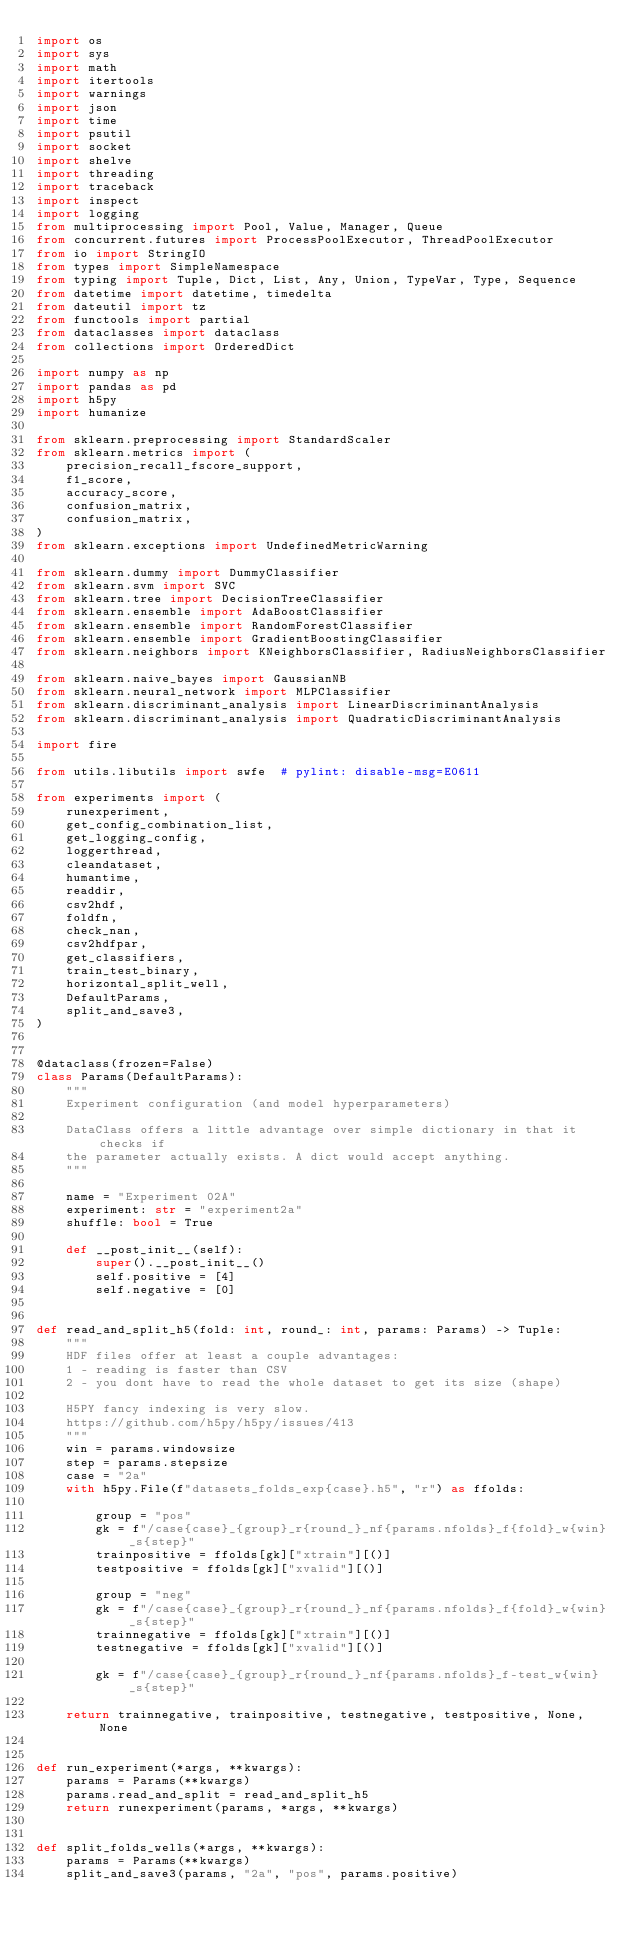Convert code to text. <code><loc_0><loc_0><loc_500><loc_500><_Python_>import os
import sys
import math
import itertools
import warnings
import json
import time
import psutil
import socket
import shelve
import threading
import traceback
import inspect
import logging
from multiprocessing import Pool, Value, Manager, Queue
from concurrent.futures import ProcessPoolExecutor, ThreadPoolExecutor
from io import StringIO
from types import SimpleNamespace
from typing import Tuple, Dict, List, Any, Union, TypeVar, Type, Sequence
from datetime import datetime, timedelta
from dateutil import tz
from functools import partial
from dataclasses import dataclass
from collections import OrderedDict

import numpy as np
import pandas as pd
import h5py
import humanize

from sklearn.preprocessing import StandardScaler
from sklearn.metrics import (
    precision_recall_fscore_support,
    f1_score,
    accuracy_score,
    confusion_matrix,
    confusion_matrix,
)
from sklearn.exceptions import UndefinedMetricWarning

from sklearn.dummy import DummyClassifier
from sklearn.svm import SVC
from sklearn.tree import DecisionTreeClassifier
from sklearn.ensemble import AdaBoostClassifier
from sklearn.ensemble import RandomForestClassifier
from sklearn.ensemble import GradientBoostingClassifier
from sklearn.neighbors import KNeighborsClassifier, RadiusNeighborsClassifier

from sklearn.naive_bayes import GaussianNB
from sklearn.neural_network import MLPClassifier
from sklearn.discriminant_analysis import LinearDiscriminantAnalysis
from sklearn.discriminant_analysis import QuadraticDiscriminantAnalysis

import fire

from utils.libutils import swfe  # pylint: disable-msg=E0611

from experiments import (
    runexperiment,
    get_config_combination_list,
    get_logging_config,
    loggerthread,
    cleandataset,
    humantime,
    readdir,
    csv2hdf,
    foldfn,
    check_nan,
    csv2hdfpar,
    get_classifiers,
    train_test_binary,
    horizontal_split_well,
    DefaultParams,
    split_and_save3,
)


@dataclass(frozen=False)
class Params(DefaultParams):
    """
    Experiment configuration (and model hyperparameters)

    DataClass offers a little advantage over simple dictionary in that it checks if
    the parameter actually exists. A dict would accept anything.
    """

    name = "Experiment 02A"
    experiment: str = "experiment2a"
    shuffle: bool = True

    def __post_init__(self):
        super().__post_init__()
        self.positive = [4]
        self.negative = [0]


def read_and_split_h5(fold: int, round_: int, params: Params) -> Tuple:
    """
    HDF files offer at least a couple advantages:
    1 - reading is faster than CSV
    2 - you dont have to read the whole dataset to get its size (shape)

    H5PY fancy indexing is very slow.
    https://github.com/h5py/h5py/issues/413
    """
    win = params.windowsize
    step = params.stepsize
    case = "2a"
    with h5py.File(f"datasets_folds_exp{case}.h5", "r") as ffolds:

        group = "pos"
        gk = f"/case{case}_{group}_r{round_}_nf{params.nfolds}_f{fold}_w{win}_s{step}"
        trainpositive = ffolds[gk]["xtrain"][()]
        testpositive = ffolds[gk]["xvalid"][()]

        group = "neg"
        gk = f"/case{case}_{group}_r{round_}_nf{params.nfolds}_f{fold}_w{win}_s{step}"
        trainnegative = ffolds[gk]["xtrain"][()]
        testnegative = ffolds[gk]["xvalid"][()]

        gk = f"/case{case}_{group}_r{round_}_nf{params.nfolds}_f-test_w{win}_s{step}"

    return trainnegative, trainpositive, testnegative, testpositive, None, None


def run_experiment(*args, **kwargs):
    params = Params(**kwargs)
    params.read_and_split = read_and_split_h5
    return runexperiment(params, *args, **kwargs)


def split_folds_wells(*args, **kwargs):
    params = Params(**kwargs)
    split_and_save3(params, "2a", "pos", params.positive)</code> 